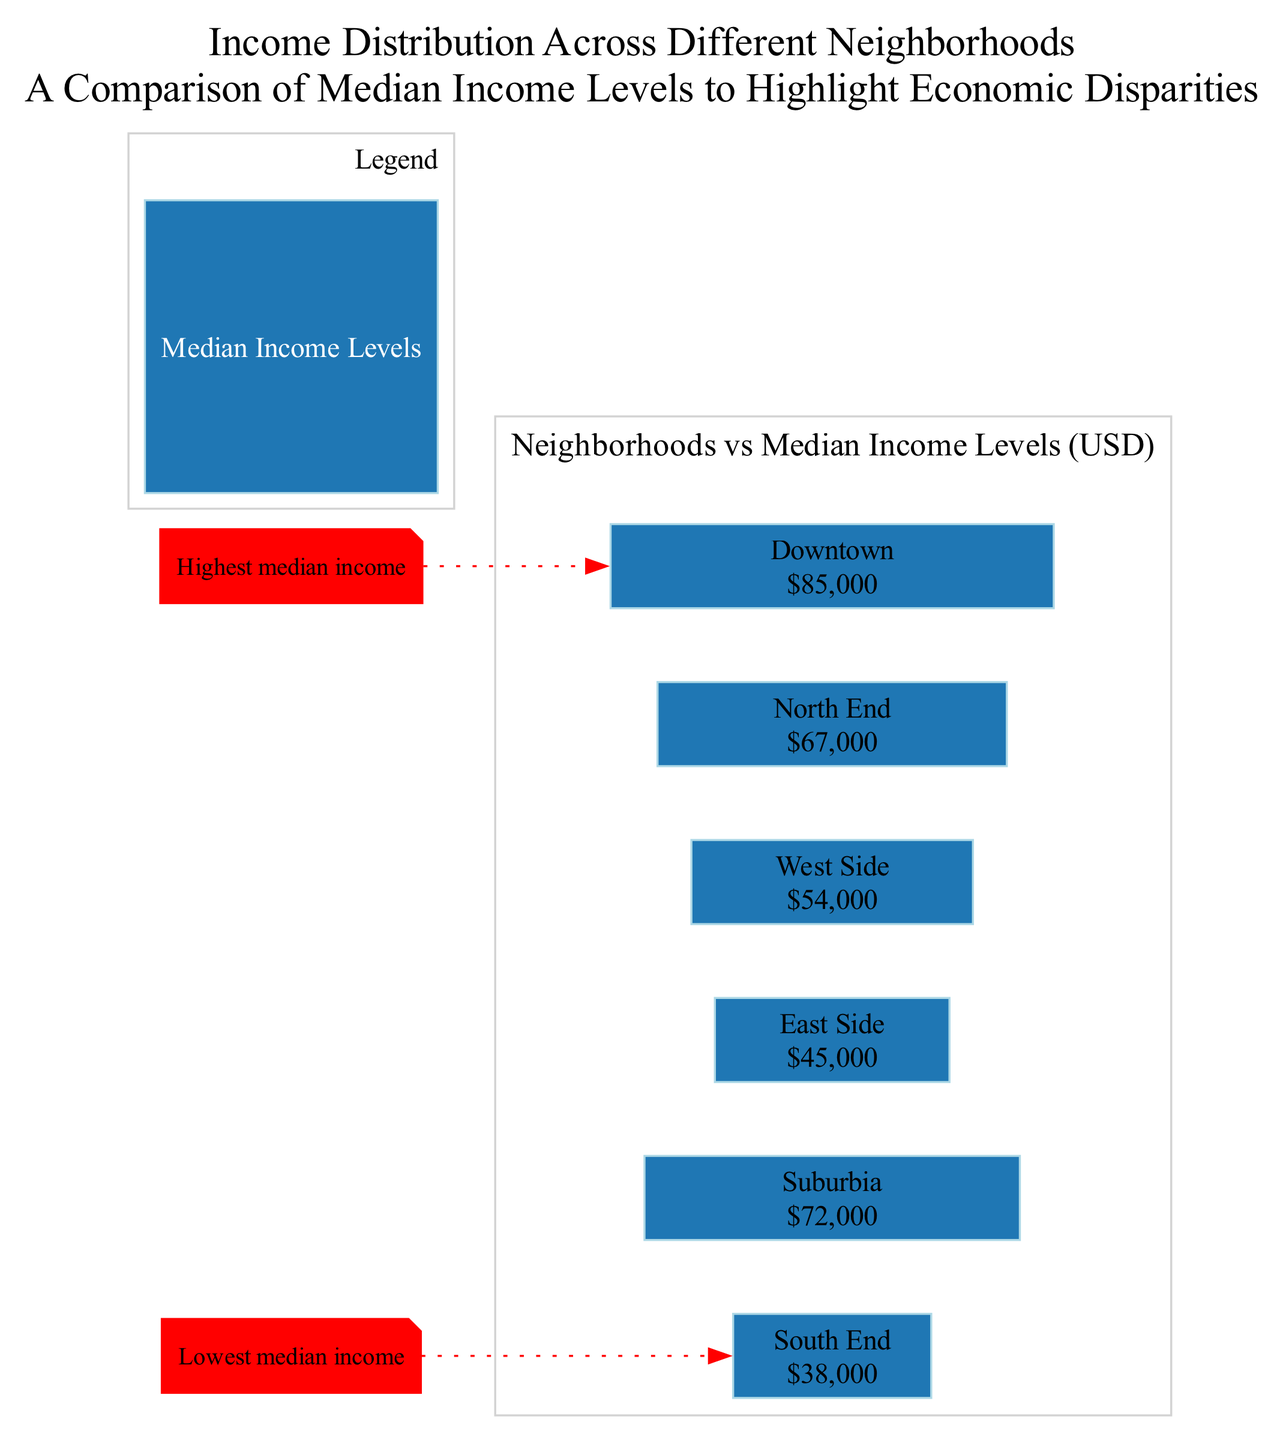What is the median income for the Downtown neighborhood? The diagram displays a specific bar for the Downtown neighborhood, which is labeled with its median income value. The label shows that the median income for Downtown is 85000 USD.
Answer: 85000 Which neighborhood has the lowest median income? The diagram includes an annotation indicating the neighborhood with the lowest median income. The South End is marked as having the lowest median income in the community.
Answer: South End How many neighborhoods are displayed in the diagram? By counting the individual neighborhood entries in the diagram, it is clear there are six neighborhoods represented: Downtown, Suburbia, East Side, West Side, North End, and South End.
Answer: 6 What is the median income level for the South End? The South End neighborhood is indicated in the diagram with a label that displays its median income as 38000 USD.
Answer: 38000 Which neighborhood's median income is closest to 70000 USD? Looking at the income values, Suburbia has a median income of 72000 USD, which is the closest to 70000 USD compared to other neighborhoods.
Answer: Suburbia What annotation is shown for the Downtown neighborhood? The diagram contains a specific annotation pertaining to the Downtown neighborhood that states it has the highest median income, which highlights its position in the income distribution.
Answer: Highest median income What is the median income for the West Side? The West Side is represented in the diagram with a specific income label stating that its median income is 54000 USD.
Answer: 54000 Which color represents the median income levels in the diagram? The diagram legend indicates a specific color that represents median income levels, which is light blue.
Answer: Light blue 